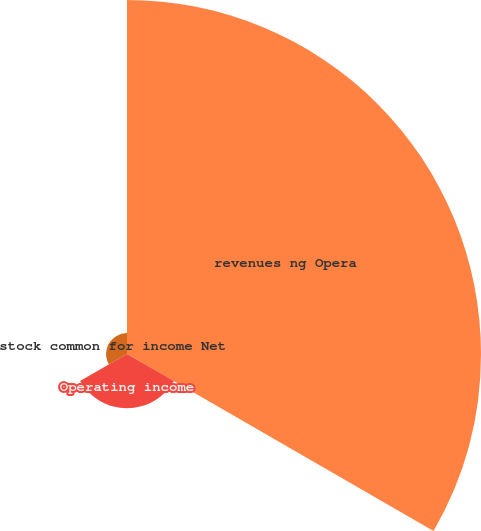<chart> <loc_0><loc_0><loc_500><loc_500><pie_chart><fcel>revenues ng Opera<fcel>Operating income<fcel>stock common for income Net<nl><fcel>82.5%<fcel>12.63%<fcel>4.87%<nl></chart> 